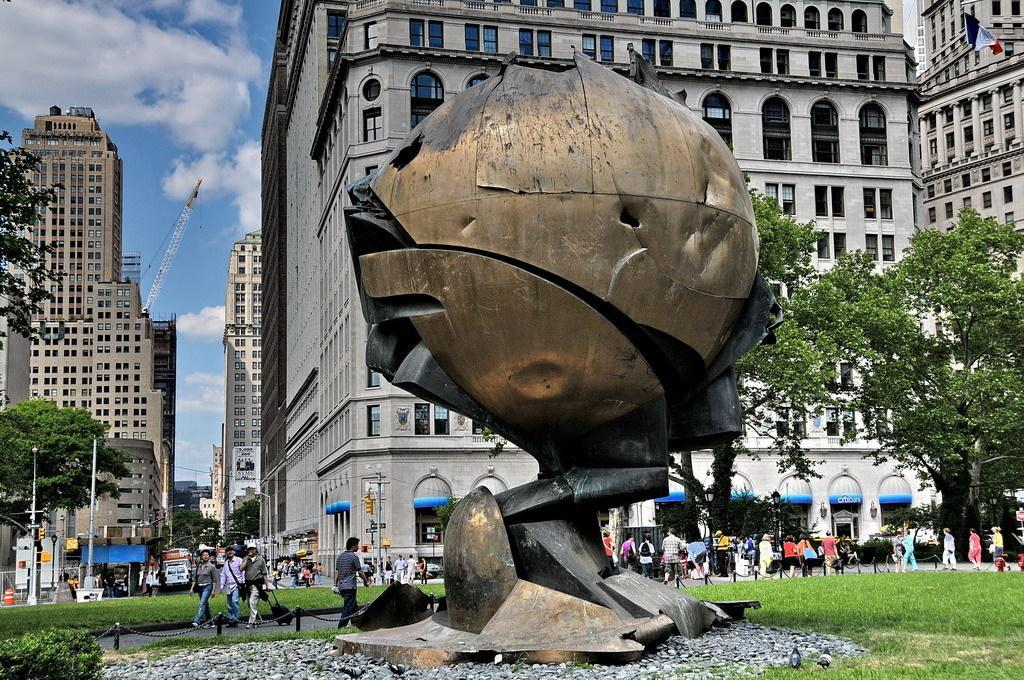Can you describe this image briefly? In the image there is a statue in the front with grassland behind it and trees on it, over the background there are buildings on either side with people in front of it walking on the road and above its sky with clouds. 